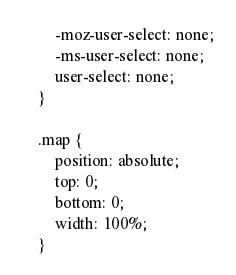<code> <loc_0><loc_0><loc_500><loc_500><_CSS_>        -moz-user-select: none;
        -ms-user-select: none;
        user-select: none;
    }

    .map {
        position: absolute;
        top: 0;
        bottom: 0;
        width: 100%;
    }
</code> 